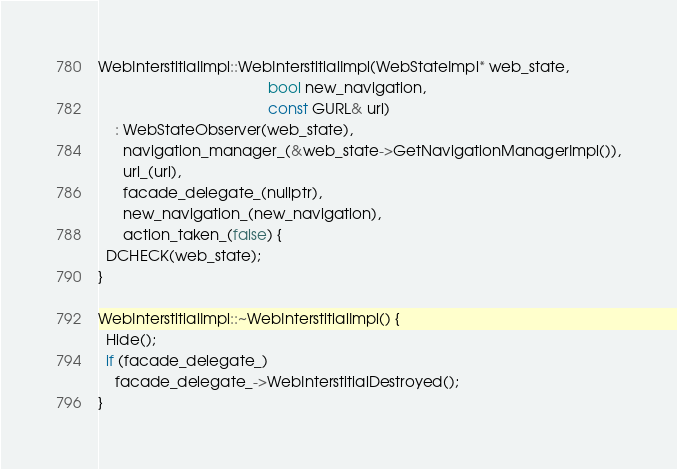<code> <loc_0><loc_0><loc_500><loc_500><_ObjectiveC_>
WebInterstitialImpl::WebInterstitialImpl(WebStateImpl* web_state,
                                         bool new_navigation,
                                         const GURL& url)
    : WebStateObserver(web_state),
      navigation_manager_(&web_state->GetNavigationManagerImpl()),
      url_(url),
      facade_delegate_(nullptr),
      new_navigation_(new_navigation),
      action_taken_(false) {
  DCHECK(web_state);
}

WebInterstitialImpl::~WebInterstitialImpl() {
  Hide();
  if (facade_delegate_)
    facade_delegate_->WebInterstitialDestroyed();
}
</code> 